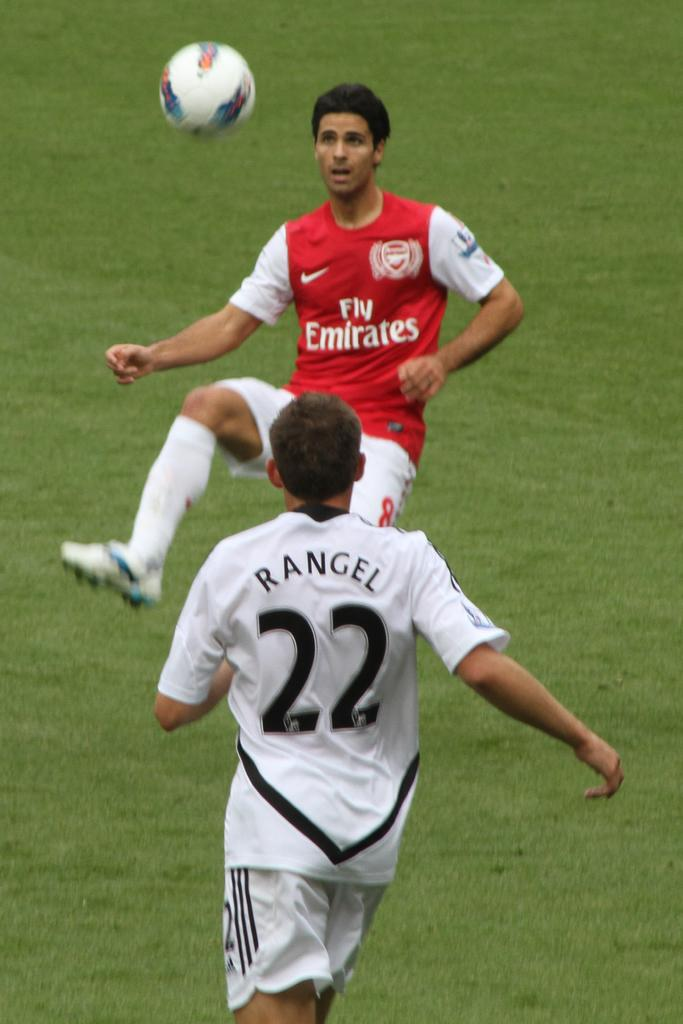Provide a one-sentence caption for the provided image. An Emirates soccer player with a lifted leg is in front of the ball in the air. 